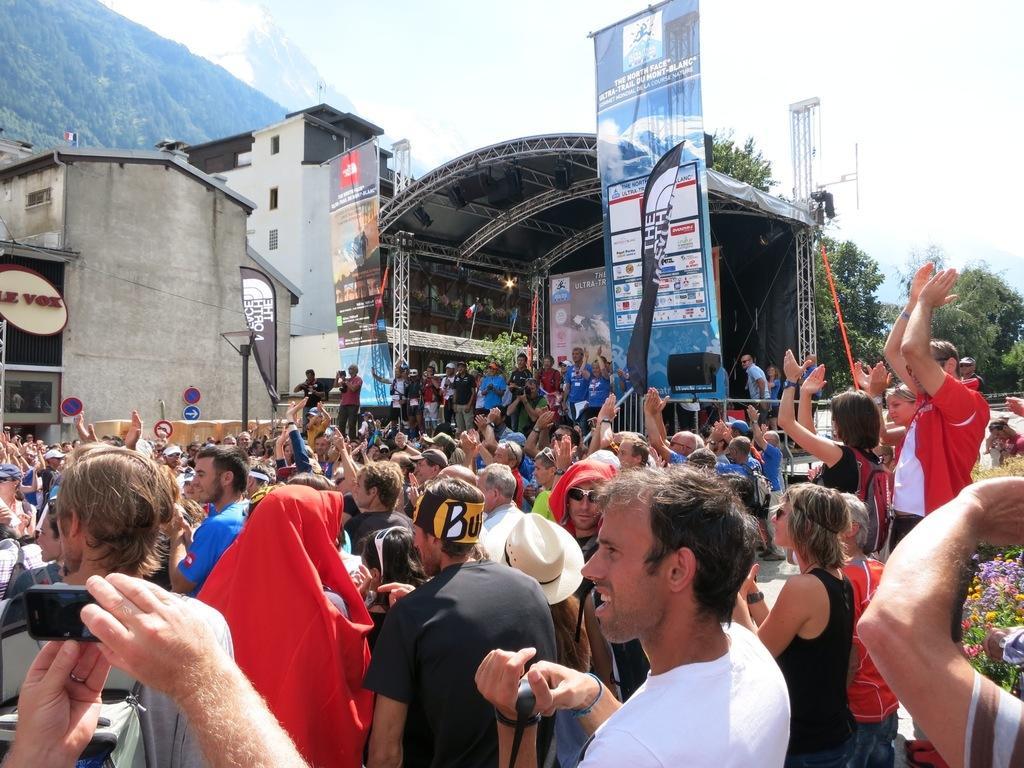How would you summarize this image in a sentence or two? In the image I can see a place where we have some people who are standing and also I can see some buildings and a screen under the roof, trees, poles and a hill to the side. 